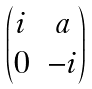Convert formula to latex. <formula><loc_0><loc_0><loc_500><loc_500>\begin{pmatrix} i & a \\ 0 & - i \end{pmatrix}</formula> 